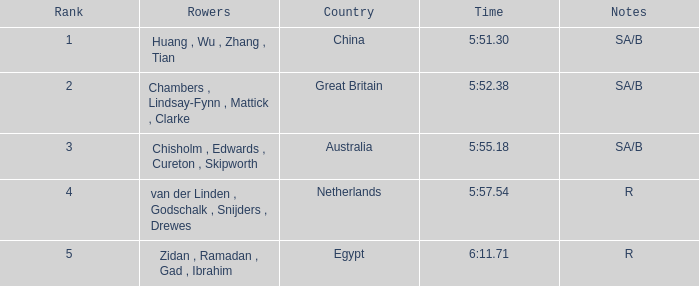Who were the rowers when notes were sa/b, with a time of 5:51.30? Huang , Wu , Zhang , Tian. 